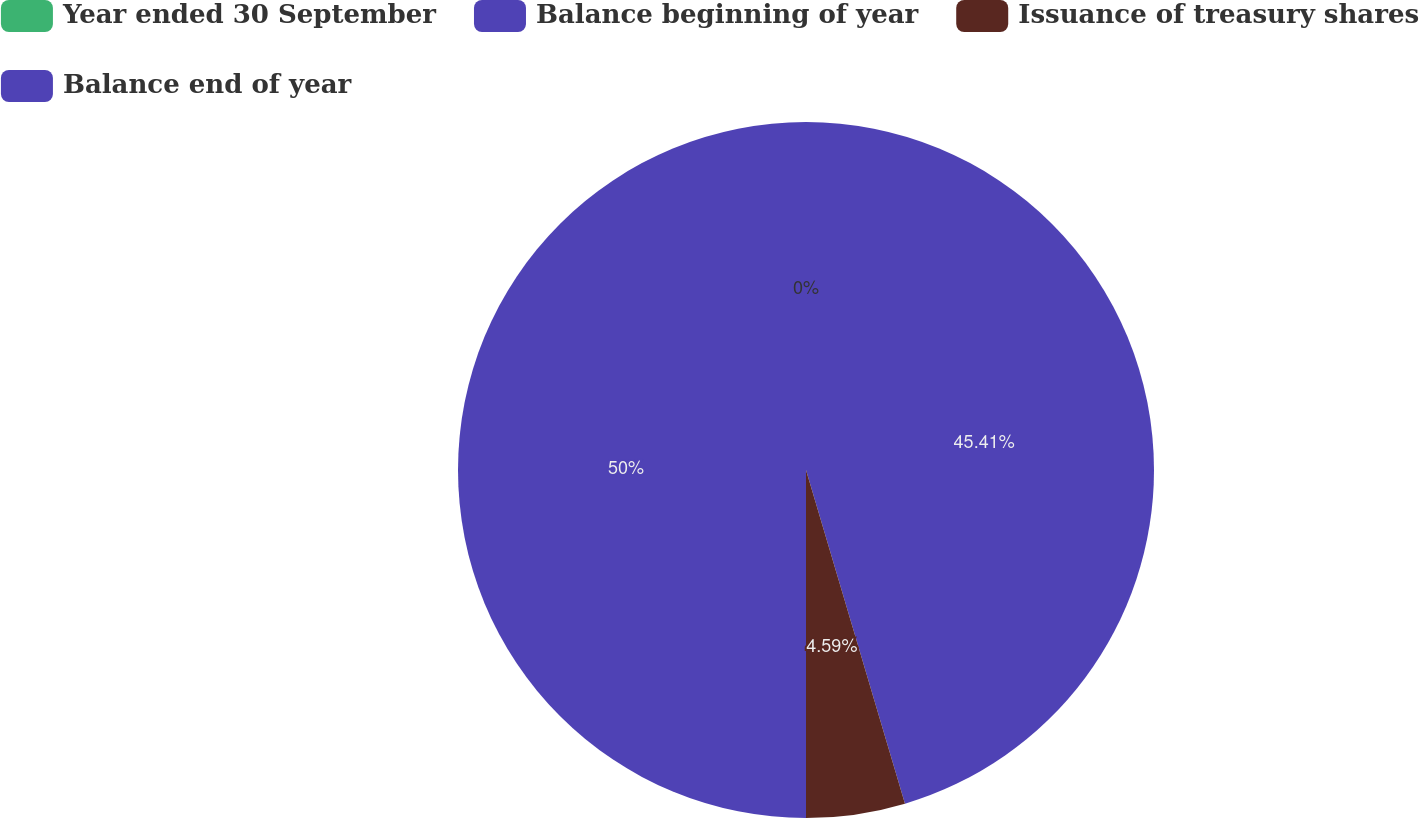<chart> <loc_0><loc_0><loc_500><loc_500><pie_chart><fcel>Year ended 30 September<fcel>Balance beginning of year<fcel>Issuance of treasury shares<fcel>Balance end of year<nl><fcel>0.0%<fcel>45.41%<fcel>4.59%<fcel>50.0%<nl></chart> 